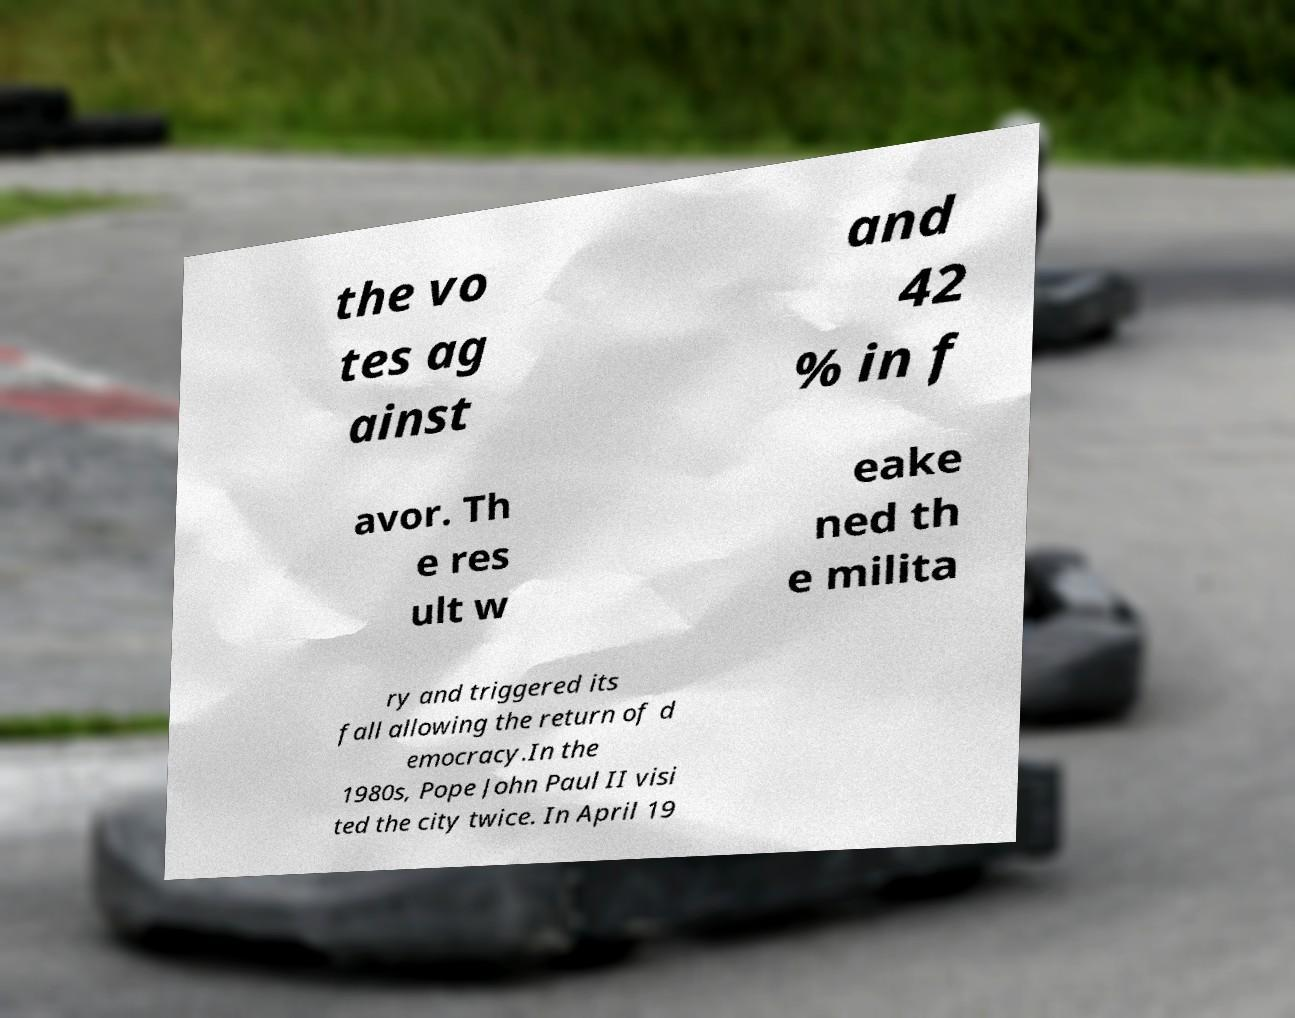For documentation purposes, I need the text within this image transcribed. Could you provide that? the vo tes ag ainst and 42 % in f avor. Th e res ult w eake ned th e milita ry and triggered its fall allowing the return of d emocracy.In the 1980s, Pope John Paul II visi ted the city twice. In April 19 